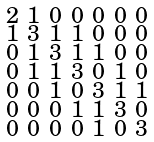<formula> <loc_0><loc_0><loc_500><loc_500>\begin{smallmatrix} 2 & 1 & 0 & 0 & 0 & 0 & 0 \\ 1 & 3 & 1 & 1 & 0 & 0 & 0 \\ 0 & 1 & 3 & 1 & 1 & 0 & 0 \\ 0 & 1 & 1 & 3 & 0 & 1 & 0 \\ 0 & 0 & 1 & 0 & 3 & 1 & 1 \\ 0 & 0 & 0 & 1 & 1 & 3 & 0 \\ 0 & 0 & 0 & 0 & 1 & 0 & 3 \end{smallmatrix}</formula> 